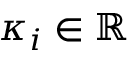<formula> <loc_0><loc_0><loc_500><loc_500>\kappa _ { i } \in \mathbb { R }</formula> 